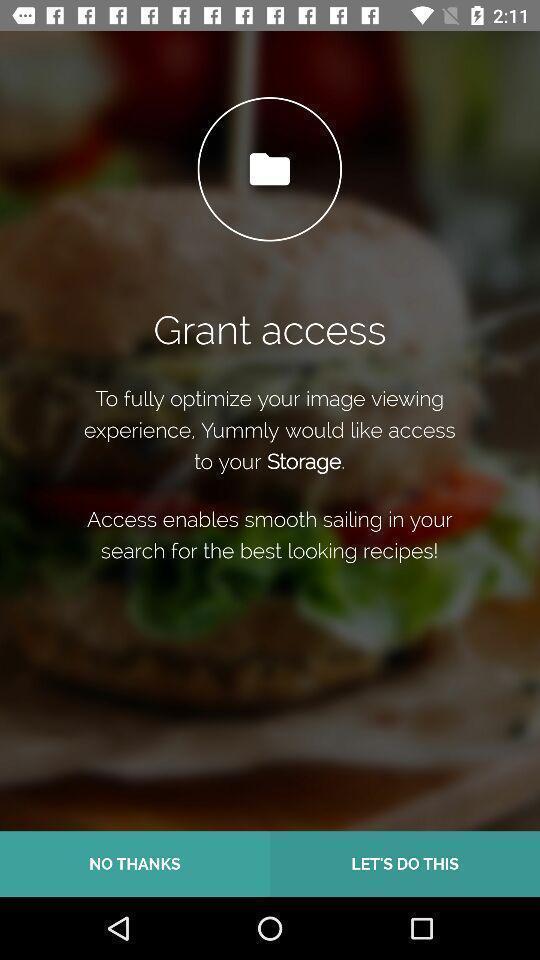Give me a narrative description of this picture. Welcome page of a recipe app asking to grant access. 